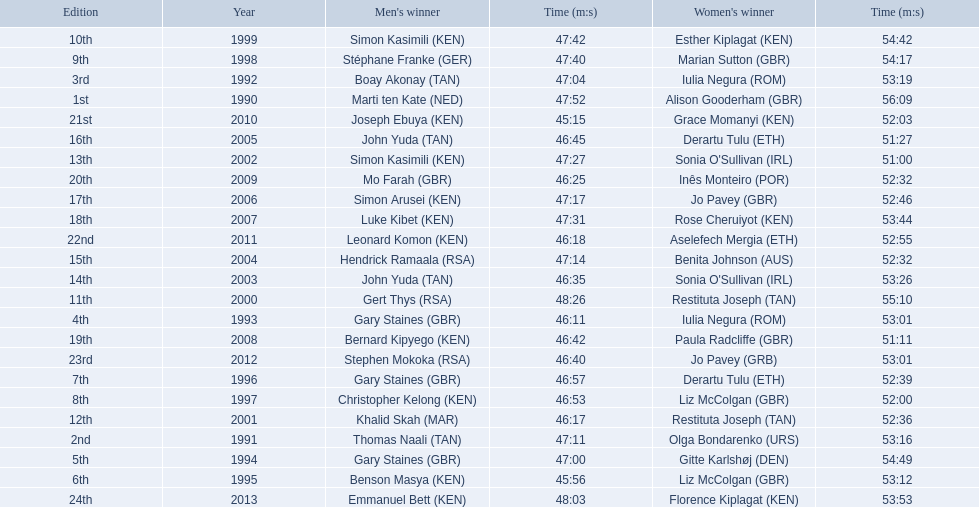What are the names of each male winner? Marti ten Kate (NED), Thomas Naali (TAN), Boay Akonay (TAN), Gary Staines (GBR), Gary Staines (GBR), Benson Masya (KEN), Gary Staines (GBR), Christopher Kelong (KEN), Stéphane Franke (GER), Simon Kasimili (KEN), Gert Thys (RSA), Khalid Skah (MAR), Simon Kasimili (KEN), John Yuda (TAN), Hendrick Ramaala (RSA), John Yuda (TAN), Simon Arusei (KEN), Luke Kibet (KEN), Bernard Kipyego (KEN), Mo Farah (GBR), Joseph Ebuya (KEN), Leonard Komon (KEN), Stephen Mokoka (RSA), Emmanuel Bett (KEN). When did they race? 1990, 1991, 1992, 1993, 1994, 1995, 1996, 1997, 1998, 1999, 2000, 2001, 2002, 2003, 2004, 2005, 2006, 2007, 2008, 2009, 2010, 2011, 2012, 2013. And what were their times? 47:52, 47:11, 47:04, 46:11, 47:00, 45:56, 46:57, 46:53, 47:40, 47:42, 48:26, 46:17, 47:27, 46:35, 47:14, 46:45, 47:17, 47:31, 46:42, 46:25, 45:15, 46:18, 46:40, 48:03. Of those times, which athlete had the fastest time? Joseph Ebuya (KEN). 